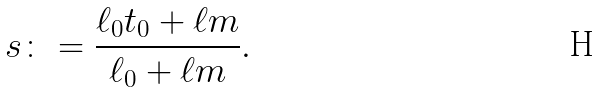Convert formula to latex. <formula><loc_0><loc_0><loc_500><loc_500>s \colon = \frac { \ell _ { 0 } t _ { 0 } + \ell m } { \ell _ { 0 } + \ell m } .</formula> 